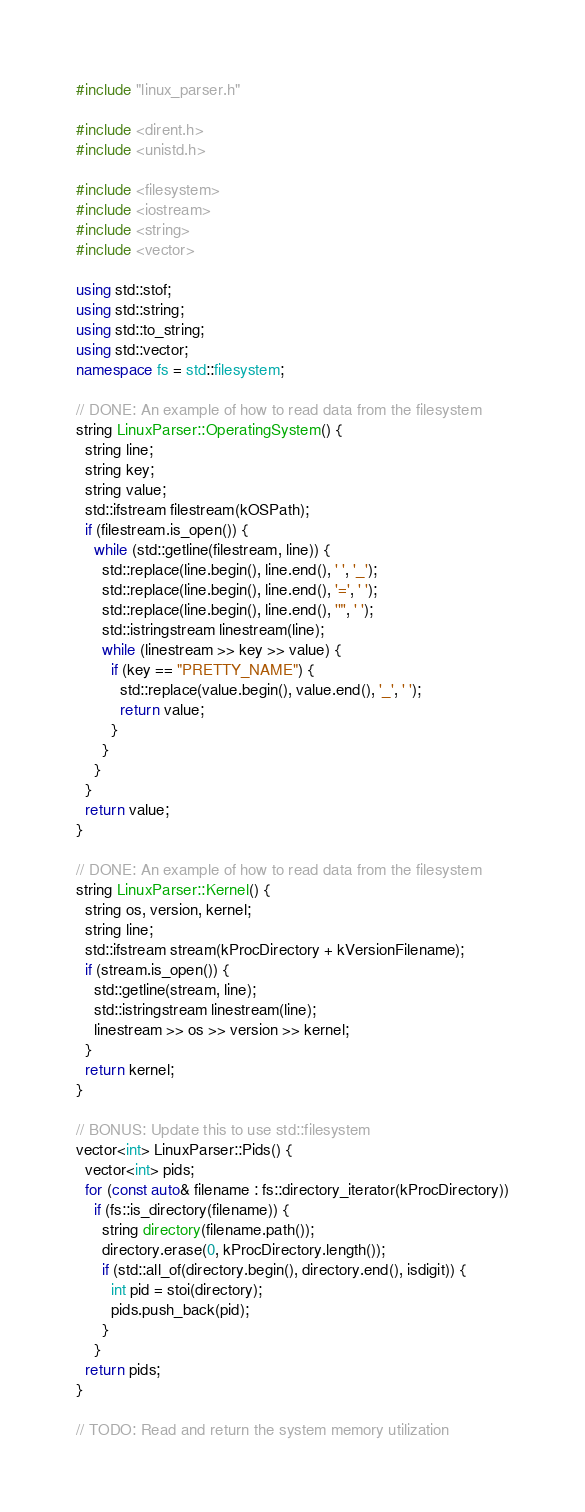Convert code to text. <code><loc_0><loc_0><loc_500><loc_500><_C++_>#include "linux_parser.h"

#include <dirent.h>
#include <unistd.h>

#include <filesystem>
#include <iostream>
#include <string>
#include <vector>

using std::stof;
using std::string;
using std::to_string;
using std::vector;
namespace fs = std::filesystem;

// DONE: An example of how to read data from the filesystem
string LinuxParser::OperatingSystem() {
  string line;
  string key;
  string value;
  std::ifstream filestream(kOSPath);
  if (filestream.is_open()) {
    while (std::getline(filestream, line)) {
      std::replace(line.begin(), line.end(), ' ', '_');
      std::replace(line.begin(), line.end(), '=', ' ');
      std::replace(line.begin(), line.end(), '"', ' ');
      std::istringstream linestream(line);
      while (linestream >> key >> value) {
        if (key == "PRETTY_NAME") {
          std::replace(value.begin(), value.end(), '_', ' ');
          return value;
        }
      }
    }
  }
  return value;
}

// DONE: An example of how to read data from the filesystem
string LinuxParser::Kernel() {
  string os, version, kernel;
  string line;
  std::ifstream stream(kProcDirectory + kVersionFilename);
  if (stream.is_open()) {
    std::getline(stream, line);
    std::istringstream linestream(line);
    linestream >> os >> version >> kernel;
  }
  return kernel;
}

// BONUS: Update this to use std::filesystem
vector<int> LinuxParser::Pids() {
  vector<int> pids;
  for (const auto& filename : fs::directory_iterator(kProcDirectory))
    if (fs::is_directory(filename)) {
      string directory(filename.path());
      directory.erase(0, kProcDirectory.length());
      if (std::all_of(directory.begin(), directory.end(), isdigit)) {
        int pid = stoi(directory);
        pids.push_back(pid);
      }
    }
  return pids;
}

// TODO: Read and return the system memory utilization</code> 